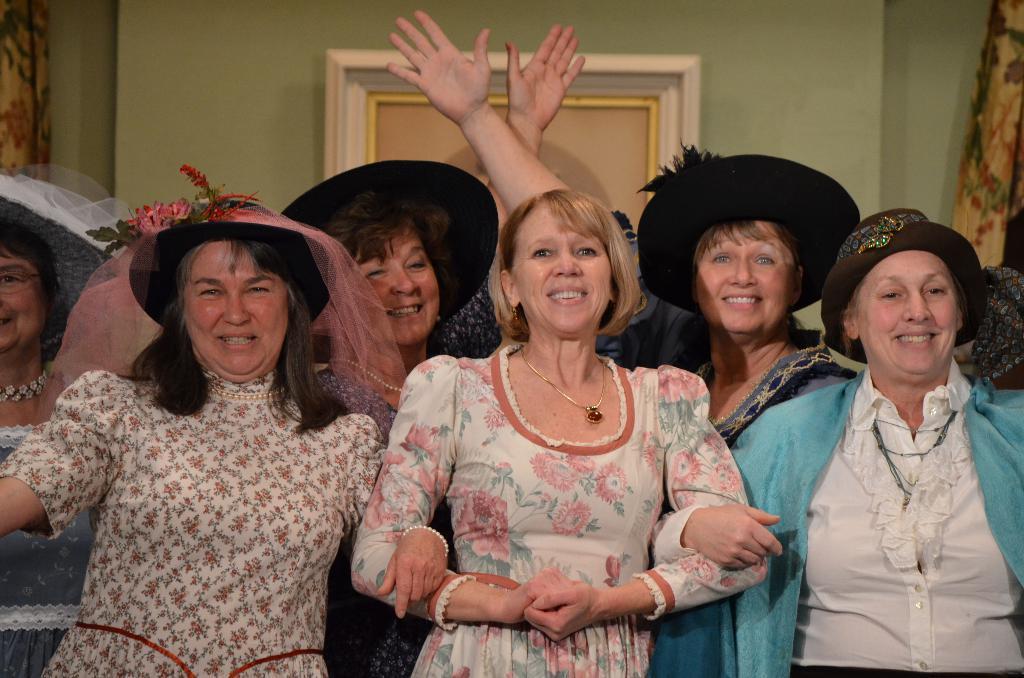What is happening in the image? There is a group of people standing in the image. What can be seen in the background of the image? There is a curtain and a frame attached to a wall in the background of the image. How many birds are rubbing their beaks together in the image? There are no birds present in the image, so it is not possible to answer that question. 